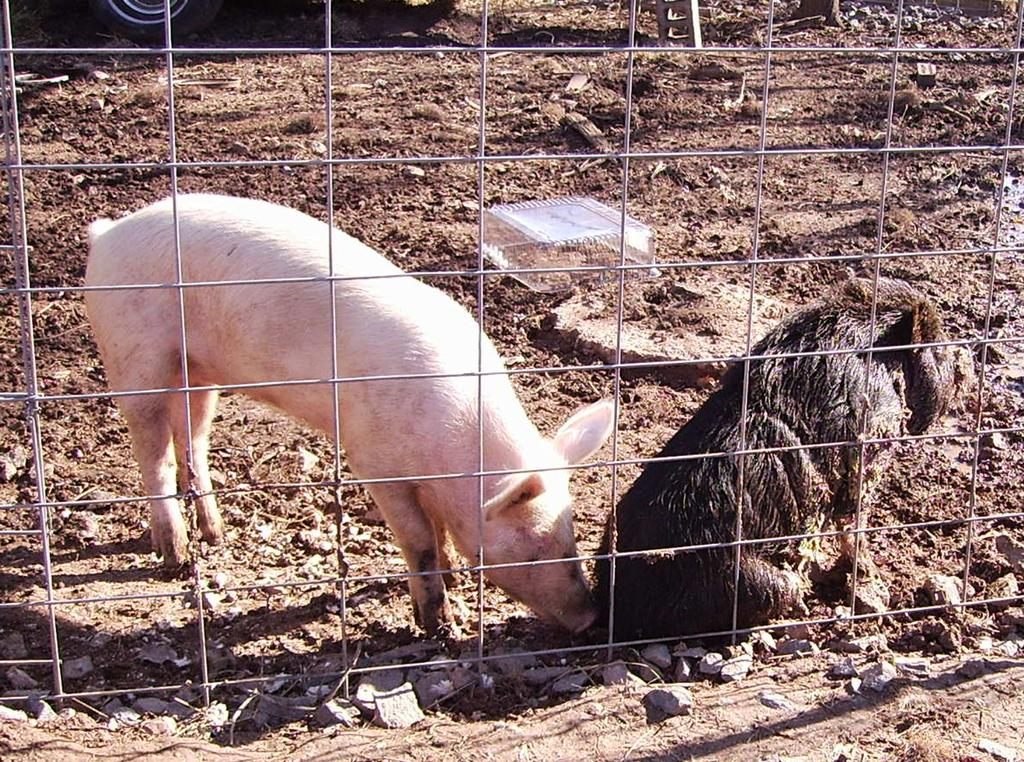What is located in the front of the image? There is fencing in the front of the image. What animals are behind the fencing? There are two pigs behind the fencing. What object can be seen in the image that is made of plastic? There is a plastic box in the image. What part of a vehicle can be seen in the top left side of the image? A wheel of a vehicle is visible in the top left side of the image. Where is the door to the tub located in the image? There is no tub or door present in the image. What type of tramp can be seen interacting with the pigs in the image? There is no tramp present in the image; only the pigs, fencing, and other objects mentioned in the facts are visible. 